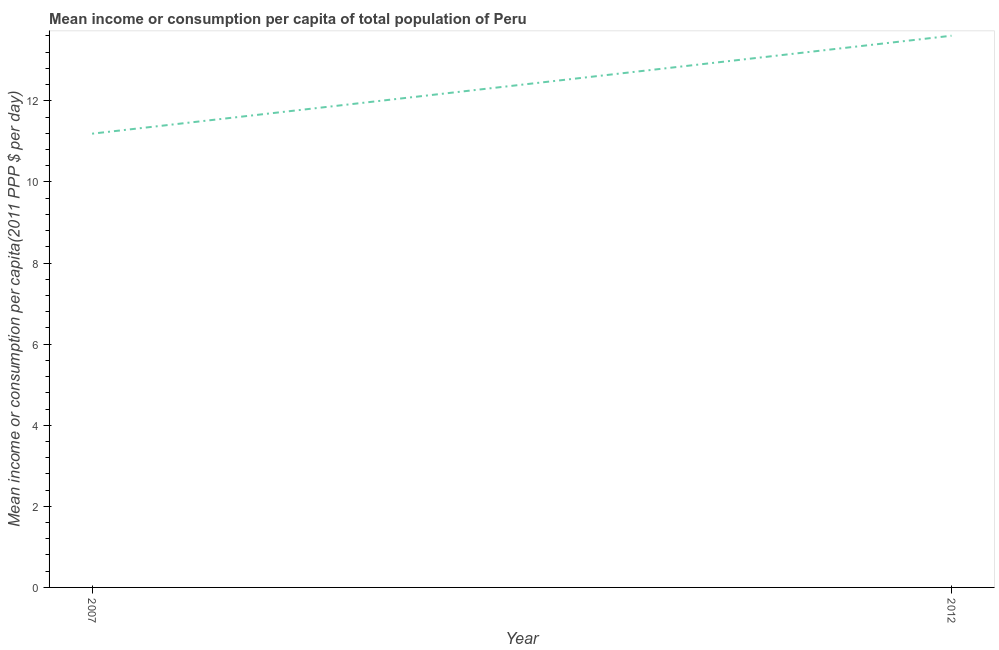What is the mean income or consumption in 2007?
Ensure brevity in your answer.  11.19. Across all years, what is the maximum mean income or consumption?
Make the answer very short. 13.61. Across all years, what is the minimum mean income or consumption?
Provide a short and direct response. 11.19. What is the sum of the mean income or consumption?
Your answer should be compact. 24.79. What is the difference between the mean income or consumption in 2007 and 2012?
Your response must be concise. -2.42. What is the average mean income or consumption per year?
Offer a terse response. 12.4. What is the median mean income or consumption?
Give a very brief answer. 12.4. What is the ratio of the mean income or consumption in 2007 to that in 2012?
Give a very brief answer. 0.82. Is the mean income or consumption in 2007 less than that in 2012?
Provide a short and direct response. Yes. Does the mean income or consumption monotonically increase over the years?
Offer a terse response. Yes. How many lines are there?
Your answer should be very brief. 1. How many years are there in the graph?
Make the answer very short. 2. What is the difference between two consecutive major ticks on the Y-axis?
Offer a terse response. 2. Does the graph contain any zero values?
Offer a terse response. No. Does the graph contain grids?
Keep it short and to the point. No. What is the title of the graph?
Offer a very short reply. Mean income or consumption per capita of total population of Peru. What is the label or title of the Y-axis?
Ensure brevity in your answer.  Mean income or consumption per capita(2011 PPP $ per day). What is the Mean income or consumption per capita(2011 PPP $ per day) in 2007?
Your answer should be compact. 11.19. What is the Mean income or consumption per capita(2011 PPP $ per day) in 2012?
Give a very brief answer. 13.61. What is the difference between the Mean income or consumption per capita(2011 PPP $ per day) in 2007 and 2012?
Ensure brevity in your answer.  -2.42. What is the ratio of the Mean income or consumption per capita(2011 PPP $ per day) in 2007 to that in 2012?
Provide a succinct answer. 0.82. 